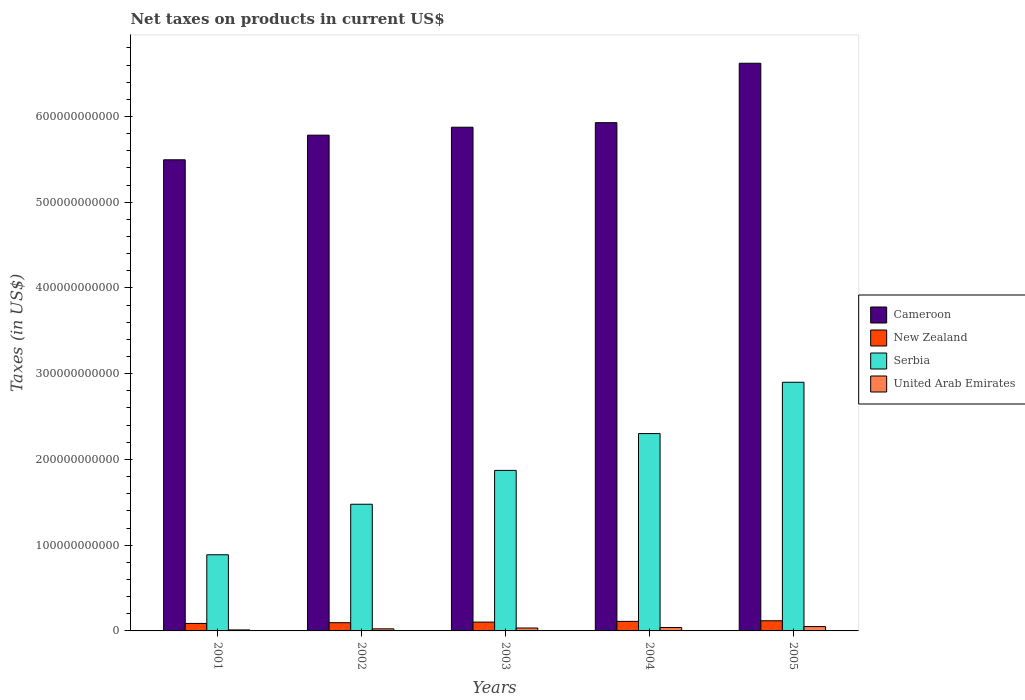Are the number of bars per tick equal to the number of legend labels?
Offer a terse response. Yes. How many bars are there on the 2nd tick from the left?
Provide a short and direct response. 4. In how many cases, is the number of bars for a given year not equal to the number of legend labels?
Your answer should be compact. 0. What is the net taxes on products in New Zealand in 2002?
Provide a succinct answer. 9.59e+09. Across all years, what is the maximum net taxes on products in Cameroon?
Your answer should be very brief. 6.62e+11. Across all years, what is the minimum net taxes on products in New Zealand?
Make the answer very short. 8.74e+09. In which year was the net taxes on products in Cameroon minimum?
Provide a succinct answer. 2001. What is the total net taxes on products in Cameroon in the graph?
Provide a short and direct response. 2.97e+12. What is the difference between the net taxes on products in United Arab Emirates in 2002 and that in 2003?
Your answer should be very brief. -9.66e+08. What is the difference between the net taxes on products in Cameroon in 2001 and the net taxes on products in New Zealand in 2002?
Provide a succinct answer. 5.40e+11. What is the average net taxes on products in Serbia per year?
Provide a succinct answer. 1.89e+11. In the year 2001, what is the difference between the net taxes on products in Serbia and net taxes on products in United Arab Emirates?
Provide a succinct answer. 8.76e+1. What is the ratio of the net taxes on products in United Arab Emirates in 2001 to that in 2005?
Ensure brevity in your answer.  0.23. Is the net taxes on products in United Arab Emirates in 2001 less than that in 2002?
Keep it short and to the point. Yes. Is the difference between the net taxes on products in Serbia in 2003 and 2004 greater than the difference between the net taxes on products in United Arab Emirates in 2003 and 2004?
Keep it short and to the point. No. What is the difference between the highest and the second highest net taxes on products in New Zealand?
Your answer should be very brief. 6.97e+08. What is the difference between the highest and the lowest net taxes on products in New Zealand?
Make the answer very short. 3.10e+09. In how many years, is the net taxes on products in New Zealand greater than the average net taxes on products in New Zealand taken over all years?
Keep it short and to the point. 2. Is the sum of the net taxes on products in United Arab Emirates in 2002 and 2004 greater than the maximum net taxes on products in New Zealand across all years?
Keep it short and to the point. No. What does the 1st bar from the left in 2003 represents?
Your answer should be very brief. Cameroon. What does the 1st bar from the right in 2001 represents?
Offer a terse response. United Arab Emirates. How many bars are there?
Offer a very short reply. 20. What is the difference between two consecutive major ticks on the Y-axis?
Make the answer very short. 1.00e+11. How many legend labels are there?
Ensure brevity in your answer.  4. What is the title of the graph?
Provide a short and direct response. Net taxes on products in current US$. What is the label or title of the X-axis?
Your answer should be compact. Years. What is the label or title of the Y-axis?
Provide a short and direct response. Taxes (in US$). What is the Taxes (in US$) of Cameroon in 2001?
Give a very brief answer. 5.49e+11. What is the Taxes (in US$) in New Zealand in 2001?
Give a very brief answer. 8.74e+09. What is the Taxes (in US$) of Serbia in 2001?
Offer a terse response. 8.88e+1. What is the Taxes (in US$) of United Arab Emirates in 2001?
Offer a terse response. 1.17e+09. What is the Taxes (in US$) in Cameroon in 2002?
Make the answer very short. 5.78e+11. What is the Taxes (in US$) in New Zealand in 2002?
Offer a terse response. 9.59e+09. What is the Taxes (in US$) in Serbia in 2002?
Offer a very short reply. 1.48e+11. What is the Taxes (in US$) of United Arab Emirates in 2002?
Provide a short and direct response. 2.43e+09. What is the Taxes (in US$) in Cameroon in 2003?
Give a very brief answer. 5.87e+11. What is the Taxes (in US$) in New Zealand in 2003?
Give a very brief answer. 1.03e+1. What is the Taxes (in US$) in Serbia in 2003?
Your answer should be compact. 1.87e+11. What is the Taxes (in US$) in United Arab Emirates in 2003?
Offer a very short reply. 3.40e+09. What is the Taxes (in US$) of Cameroon in 2004?
Offer a terse response. 5.93e+11. What is the Taxes (in US$) in New Zealand in 2004?
Make the answer very short. 1.11e+1. What is the Taxes (in US$) of Serbia in 2004?
Keep it short and to the point. 2.30e+11. What is the Taxes (in US$) in United Arab Emirates in 2004?
Provide a short and direct response. 3.94e+09. What is the Taxes (in US$) in Cameroon in 2005?
Your response must be concise. 6.62e+11. What is the Taxes (in US$) of New Zealand in 2005?
Your answer should be compact. 1.18e+1. What is the Taxes (in US$) of Serbia in 2005?
Provide a succinct answer. 2.90e+11. What is the Taxes (in US$) in United Arab Emirates in 2005?
Ensure brevity in your answer.  5.07e+09. Across all years, what is the maximum Taxes (in US$) in Cameroon?
Ensure brevity in your answer.  6.62e+11. Across all years, what is the maximum Taxes (in US$) in New Zealand?
Keep it short and to the point. 1.18e+1. Across all years, what is the maximum Taxes (in US$) in Serbia?
Offer a very short reply. 2.90e+11. Across all years, what is the maximum Taxes (in US$) of United Arab Emirates?
Your answer should be compact. 5.07e+09. Across all years, what is the minimum Taxes (in US$) of Cameroon?
Your answer should be very brief. 5.49e+11. Across all years, what is the minimum Taxes (in US$) of New Zealand?
Keep it short and to the point. 8.74e+09. Across all years, what is the minimum Taxes (in US$) in Serbia?
Provide a succinct answer. 8.88e+1. Across all years, what is the minimum Taxes (in US$) of United Arab Emirates?
Provide a short and direct response. 1.17e+09. What is the total Taxes (in US$) in Cameroon in the graph?
Keep it short and to the point. 2.97e+12. What is the total Taxes (in US$) in New Zealand in the graph?
Offer a terse response. 5.16e+1. What is the total Taxes (in US$) in Serbia in the graph?
Offer a terse response. 9.44e+11. What is the total Taxes (in US$) of United Arab Emirates in the graph?
Make the answer very short. 1.60e+1. What is the difference between the Taxes (in US$) of Cameroon in 2001 and that in 2002?
Your answer should be compact. -2.87e+1. What is the difference between the Taxes (in US$) of New Zealand in 2001 and that in 2002?
Keep it short and to the point. -8.53e+08. What is the difference between the Taxes (in US$) in Serbia in 2001 and that in 2002?
Provide a short and direct response. -5.89e+1. What is the difference between the Taxes (in US$) in United Arab Emirates in 2001 and that in 2002?
Offer a terse response. -1.26e+09. What is the difference between the Taxes (in US$) of Cameroon in 2001 and that in 2003?
Your answer should be compact. -3.80e+1. What is the difference between the Taxes (in US$) in New Zealand in 2001 and that in 2003?
Your response must be concise. -1.55e+09. What is the difference between the Taxes (in US$) of Serbia in 2001 and that in 2003?
Your answer should be compact. -9.84e+1. What is the difference between the Taxes (in US$) in United Arab Emirates in 2001 and that in 2003?
Offer a terse response. -2.23e+09. What is the difference between the Taxes (in US$) of Cameroon in 2001 and that in 2004?
Your answer should be compact. -4.33e+1. What is the difference between the Taxes (in US$) in New Zealand in 2001 and that in 2004?
Make the answer very short. -2.40e+09. What is the difference between the Taxes (in US$) of Serbia in 2001 and that in 2004?
Your response must be concise. -1.41e+11. What is the difference between the Taxes (in US$) in United Arab Emirates in 2001 and that in 2004?
Your answer should be compact. -2.77e+09. What is the difference between the Taxes (in US$) of Cameroon in 2001 and that in 2005?
Keep it short and to the point. -1.13e+11. What is the difference between the Taxes (in US$) of New Zealand in 2001 and that in 2005?
Make the answer very short. -3.10e+09. What is the difference between the Taxes (in US$) in Serbia in 2001 and that in 2005?
Your answer should be compact. -2.01e+11. What is the difference between the Taxes (in US$) in United Arab Emirates in 2001 and that in 2005?
Your response must be concise. -3.90e+09. What is the difference between the Taxes (in US$) of Cameroon in 2002 and that in 2003?
Offer a very short reply. -9.24e+09. What is the difference between the Taxes (in US$) in New Zealand in 2002 and that in 2003?
Provide a short and direct response. -6.98e+08. What is the difference between the Taxes (in US$) in Serbia in 2002 and that in 2003?
Provide a succinct answer. -3.95e+1. What is the difference between the Taxes (in US$) of United Arab Emirates in 2002 and that in 2003?
Your answer should be compact. -9.66e+08. What is the difference between the Taxes (in US$) of Cameroon in 2002 and that in 2004?
Offer a terse response. -1.46e+1. What is the difference between the Taxes (in US$) of New Zealand in 2002 and that in 2004?
Ensure brevity in your answer.  -1.55e+09. What is the difference between the Taxes (in US$) of Serbia in 2002 and that in 2004?
Your answer should be compact. -8.24e+1. What is the difference between the Taxes (in US$) of United Arab Emirates in 2002 and that in 2004?
Provide a short and direct response. -1.50e+09. What is the difference between the Taxes (in US$) of Cameroon in 2002 and that in 2005?
Keep it short and to the point. -8.39e+1. What is the difference between the Taxes (in US$) of New Zealand in 2002 and that in 2005?
Provide a short and direct response. -2.25e+09. What is the difference between the Taxes (in US$) in Serbia in 2002 and that in 2005?
Offer a terse response. -1.42e+11. What is the difference between the Taxes (in US$) of United Arab Emirates in 2002 and that in 2005?
Provide a succinct answer. -2.64e+09. What is the difference between the Taxes (in US$) in Cameroon in 2003 and that in 2004?
Keep it short and to the point. -5.34e+09. What is the difference between the Taxes (in US$) of New Zealand in 2003 and that in 2004?
Your answer should be compact. -8.52e+08. What is the difference between the Taxes (in US$) of Serbia in 2003 and that in 2004?
Offer a terse response. -4.30e+1. What is the difference between the Taxes (in US$) in United Arab Emirates in 2003 and that in 2004?
Offer a terse response. -5.39e+08. What is the difference between the Taxes (in US$) of Cameroon in 2003 and that in 2005?
Ensure brevity in your answer.  -7.46e+1. What is the difference between the Taxes (in US$) of New Zealand in 2003 and that in 2005?
Offer a very short reply. -1.55e+09. What is the difference between the Taxes (in US$) in Serbia in 2003 and that in 2005?
Your response must be concise. -1.03e+11. What is the difference between the Taxes (in US$) in United Arab Emirates in 2003 and that in 2005?
Provide a short and direct response. -1.67e+09. What is the difference between the Taxes (in US$) in Cameroon in 2004 and that in 2005?
Your response must be concise. -6.93e+1. What is the difference between the Taxes (in US$) of New Zealand in 2004 and that in 2005?
Provide a short and direct response. -6.97e+08. What is the difference between the Taxes (in US$) in Serbia in 2004 and that in 2005?
Ensure brevity in your answer.  -5.99e+1. What is the difference between the Taxes (in US$) in United Arab Emirates in 2004 and that in 2005?
Your response must be concise. -1.14e+09. What is the difference between the Taxes (in US$) of Cameroon in 2001 and the Taxes (in US$) of New Zealand in 2002?
Make the answer very short. 5.40e+11. What is the difference between the Taxes (in US$) in Cameroon in 2001 and the Taxes (in US$) in Serbia in 2002?
Offer a very short reply. 4.02e+11. What is the difference between the Taxes (in US$) in Cameroon in 2001 and the Taxes (in US$) in United Arab Emirates in 2002?
Provide a short and direct response. 5.47e+11. What is the difference between the Taxes (in US$) in New Zealand in 2001 and the Taxes (in US$) in Serbia in 2002?
Keep it short and to the point. -1.39e+11. What is the difference between the Taxes (in US$) in New Zealand in 2001 and the Taxes (in US$) in United Arab Emirates in 2002?
Your answer should be very brief. 6.31e+09. What is the difference between the Taxes (in US$) of Serbia in 2001 and the Taxes (in US$) of United Arab Emirates in 2002?
Provide a succinct answer. 8.64e+1. What is the difference between the Taxes (in US$) in Cameroon in 2001 and the Taxes (in US$) in New Zealand in 2003?
Your response must be concise. 5.39e+11. What is the difference between the Taxes (in US$) in Cameroon in 2001 and the Taxes (in US$) in Serbia in 2003?
Your answer should be very brief. 3.62e+11. What is the difference between the Taxes (in US$) of Cameroon in 2001 and the Taxes (in US$) of United Arab Emirates in 2003?
Make the answer very short. 5.46e+11. What is the difference between the Taxes (in US$) in New Zealand in 2001 and the Taxes (in US$) in Serbia in 2003?
Make the answer very short. -1.78e+11. What is the difference between the Taxes (in US$) in New Zealand in 2001 and the Taxes (in US$) in United Arab Emirates in 2003?
Offer a terse response. 5.34e+09. What is the difference between the Taxes (in US$) of Serbia in 2001 and the Taxes (in US$) of United Arab Emirates in 2003?
Give a very brief answer. 8.54e+1. What is the difference between the Taxes (in US$) of Cameroon in 2001 and the Taxes (in US$) of New Zealand in 2004?
Your response must be concise. 5.38e+11. What is the difference between the Taxes (in US$) of Cameroon in 2001 and the Taxes (in US$) of Serbia in 2004?
Offer a very short reply. 3.19e+11. What is the difference between the Taxes (in US$) of Cameroon in 2001 and the Taxes (in US$) of United Arab Emirates in 2004?
Make the answer very short. 5.46e+11. What is the difference between the Taxes (in US$) in New Zealand in 2001 and the Taxes (in US$) in Serbia in 2004?
Provide a succinct answer. -2.21e+11. What is the difference between the Taxes (in US$) of New Zealand in 2001 and the Taxes (in US$) of United Arab Emirates in 2004?
Offer a terse response. 4.80e+09. What is the difference between the Taxes (in US$) of Serbia in 2001 and the Taxes (in US$) of United Arab Emirates in 2004?
Your answer should be very brief. 8.49e+1. What is the difference between the Taxes (in US$) in Cameroon in 2001 and the Taxes (in US$) in New Zealand in 2005?
Ensure brevity in your answer.  5.38e+11. What is the difference between the Taxes (in US$) in Cameroon in 2001 and the Taxes (in US$) in Serbia in 2005?
Provide a short and direct response. 2.59e+11. What is the difference between the Taxes (in US$) of Cameroon in 2001 and the Taxes (in US$) of United Arab Emirates in 2005?
Keep it short and to the point. 5.44e+11. What is the difference between the Taxes (in US$) in New Zealand in 2001 and the Taxes (in US$) in Serbia in 2005?
Make the answer very short. -2.81e+11. What is the difference between the Taxes (in US$) in New Zealand in 2001 and the Taxes (in US$) in United Arab Emirates in 2005?
Provide a short and direct response. 3.67e+09. What is the difference between the Taxes (in US$) in Serbia in 2001 and the Taxes (in US$) in United Arab Emirates in 2005?
Provide a succinct answer. 8.37e+1. What is the difference between the Taxes (in US$) of Cameroon in 2002 and the Taxes (in US$) of New Zealand in 2003?
Ensure brevity in your answer.  5.68e+11. What is the difference between the Taxes (in US$) of Cameroon in 2002 and the Taxes (in US$) of Serbia in 2003?
Keep it short and to the point. 3.91e+11. What is the difference between the Taxes (in US$) of Cameroon in 2002 and the Taxes (in US$) of United Arab Emirates in 2003?
Your answer should be compact. 5.75e+11. What is the difference between the Taxes (in US$) in New Zealand in 2002 and the Taxes (in US$) in Serbia in 2003?
Make the answer very short. -1.78e+11. What is the difference between the Taxes (in US$) in New Zealand in 2002 and the Taxes (in US$) in United Arab Emirates in 2003?
Offer a terse response. 6.20e+09. What is the difference between the Taxes (in US$) of Serbia in 2002 and the Taxes (in US$) of United Arab Emirates in 2003?
Ensure brevity in your answer.  1.44e+11. What is the difference between the Taxes (in US$) of Cameroon in 2002 and the Taxes (in US$) of New Zealand in 2004?
Keep it short and to the point. 5.67e+11. What is the difference between the Taxes (in US$) of Cameroon in 2002 and the Taxes (in US$) of Serbia in 2004?
Provide a succinct answer. 3.48e+11. What is the difference between the Taxes (in US$) in Cameroon in 2002 and the Taxes (in US$) in United Arab Emirates in 2004?
Give a very brief answer. 5.74e+11. What is the difference between the Taxes (in US$) in New Zealand in 2002 and the Taxes (in US$) in Serbia in 2004?
Keep it short and to the point. -2.21e+11. What is the difference between the Taxes (in US$) in New Zealand in 2002 and the Taxes (in US$) in United Arab Emirates in 2004?
Provide a succinct answer. 5.66e+09. What is the difference between the Taxes (in US$) in Serbia in 2002 and the Taxes (in US$) in United Arab Emirates in 2004?
Provide a short and direct response. 1.44e+11. What is the difference between the Taxes (in US$) in Cameroon in 2002 and the Taxes (in US$) in New Zealand in 2005?
Keep it short and to the point. 5.66e+11. What is the difference between the Taxes (in US$) of Cameroon in 2002 and the Taxes (in US$) of Serbia in 2005?
Your answer should be compact. 2.88e+11. What is the difference between the Taxes (in US$) in Cameroon in 2002 and the Taxes (in US$) in United Arab Emirates in 2005?
Keep it short and to the point. 5.73e+11. What is the difference between the Taxes (in US$) in New Zealand in 2002 and the Taxes (in US$) in Serbia in 2005?
Make the answer very short. -2.80e+11. What is the difference between the Taxes (in US$) in New Zealand in 2002 and the Taxes (in US$) in United Arab Emirates in 2005?
Your answer should be compact. 4.52e+09. What is the difference between the Taxes (in US$) of Serbia in 2002 and the Taxes (in US$) of United Arab Emirates in 2005?
Provide a short and direct response. 1.43e+11. What is the difference between the Taxes (in US$) in Cameroon in 2003 and the Taxes (in US$) in New Zealand in 2004?
Ensure brevity in your answer.  5.76e+11. What is the difference between the Taxes (in US$) in Cameroon in 2003 and the Taxes (in US$) in Serbia in 2004?
Offer a terse response. 3.57e+11. What is the difference between the Taxes (in US$) in Cameroon in 2003 and the Taxes (in US$) in United Arab Emirates in 2004?
Give a very brief answer. 5.84e+11. What is the difference between the Taxes (in US$) of New Zealand in 2003 and the Taxes (in US$) of Serbia in 2004?
Your answer should be very brief. -2.20e+11. What is the difference between the Taxes (in US$) in New Zealand in 2003 and the Taxes (in US$) in United Arab Emirates in 2004?
Provide a succinct answer. 6.36e+09. What is the difference between the Taxes (in US$) in Serbia in 2003 and the Taxes (in US$) in United Arab Emirates in 2004?
Your answer should be compact. 1.83e+11. What is the difference between the Taxes (in US$) in Cameroon in 2003 and the Taxes (in US$) in New Zealand in 2005?
Your answer should be compact. 5.76e+11. What is the difference between the Taxes (in US$) of Cameroon in 2003 and the Taxes (in US$) of Serbia in 2005?
Offer a terse response. 2.97e+11. What is the difference between the Taxes (in US$) of Cameroon in 2003 and the Taxes (in US$) of United Arab Emirates in 2005?
Your answer should be very brief. 5.82e+11. What is the difference between the Taxes (in US$) of New Zealand in 2003 and the Taxes (in US$) of Serbia in 2005?
Offer a terse response. -2.80e+11. What is the difference between the Taxes (in US$) in New Zealand in 2003 and the Taxes (in US$) in United Arab Emirates in 2005?
Your answer should be compact. 5.22e+09. What is the difference between the Taxes (in US$) in Serbia in 2003 and the Taxes (in US$) in United Arab Emirates in 2005?
Keep it short and to the point. 1.82e+11. What is the difference between the Taxes (in US$) of Cameroon in 2004 and the Taxes (in US$) of New Zealand in 2005?
Give a very brief answer. 5.81e+11. What is the difference between the Taxes (in US$) in Cameroon in 2004 and the Taxes (in US$) in Serbia in 2005?
Your answer should be very brief. 3.03e+11. What is the difference between the Taxes (in US$) of Cameroon in 2004 and the Taxes (in US$) of United Arab Emirates in 2005?
Offer a very short reply. 5.88e+11. What is the difference between the Taxes (in US$) in New Zealand in 2004 and the Taxes (in US$) in Serbia in 2005?
Keep it short and to the point. -2.79e+11. What is the difference between the Taxes (in US$) of New Zealand in 2004 and the Taxes (in US$) of United Arab Emirates in 2005?
Keep it short and to the point. 6.07e+09. What is the difference between the Taxes (in US$) of Serbia in 2004 and the Taxes (in US$) of United Arab Emirates in 2005?
Provide a succinct answer. 2.25e+11. What is the average Taxes (in US$) in Cameroon per year?
Your answer should be compact. 5.94e+11. What is the average Taxes (in US$) in New Zealand per year?
Provide a succinct answer. 1.03e+1. What is the average Taxes (in US$) of Serbia per year?
Offer a terse response. 1.89e+11. What is the average Taxes (in US$) in United Arab Emirates per year?
Your answer should be compact. 3.20e+09. In the year 2001, what is the difference between the Taxes (in US$) in Cameroon and Taxes (in US$) in New Zealand?
Keep it short and to the point. 5.41e+11. In the year 2001, what is the difference between the Taxes (in US$) in Cameroon and Taxes (in US$) in Serbia?
Offer a very short reply. 4.61e+11. In the year 2001, what is the difference between the Taxes (in US$) in Cameroon and Taxes (in US$) in United Arab Emirates?
Provide a succinct answer. 5.48e+11. In the year 2001, what is the difference between the Taxes (in US$) of New Zealand and Taxes (in US$) of Serbia?
Your answer should be compact. -8.01e+1. In the year 2001, what is the difference between the Taxes (in US$) of New Zealand and Taxes (in US$) of United Arab Emirates?
Offer a very short reply. 7.57e+09. In the year 2001, what is the difference between the Taxes (in US$) in Serbia and Taxes (in US$) in United Arab Emirates?
Your response must be concise. 8.76e+1. In the year 2002, what is the difference between the Taxes (in US$) of Cameroon and Taxes (in US$) of New Zealand?
Keep it short and to the point. 5.69e+11. In the year 2002, what is the difference between the Taxes (in US$) in Cameroon and Taxes (in US$) in Serbia?
Your answer should be very brief. 4.30e+11. In the year 2002, what is the difference between the Taxes (in US$) in Cameroon and Taxes (in US$) in United Arab Emirates?
Make the answer very short. 5.76e+11. In the year 2002, what is the difference between the Taxes (in US$) of New Zealand and Taxes (in US$) of Serbia?
Provide a short and direct response. -1.38e+11. In the year 2002, what is the difference between the Taxes (in US$) of New Zealand and Taxes (in US$) of United Arab Emirates?
Your response must be concise. 7.16e+09. In the year 2002, what is the difference between the Taxes (in US$) of Serbia and Taxes (in US$) of United Arab Emirates?
Provide a short and direct response. 1.45e+11. In the year 2003, what is the difference between the Taxes (in US$) of Cameroon and Taxes (in US$) of New Zealand?
Give a very brief answer. 5.77e+11. In the year 2003, what is the difference between the Taxes (in US$) of Cameroon and Taxes (in US$) of Serbia?
Provide a short and direct response. 4.00e+11. In the year 2003, what is the difference between the Taxes (in US$) in Cameroon and Taxes (in US$) in United Arab Emirates?
Make the answer very short. 5.84e+11. In the year 2003, what is the difference between the Taxes (in US$) of New Zealand and Taxes (in US$) of Serbia?
Ensure brevity in your answer.  -1.77e+11. In the year 2003, what is the difference between the Taxes (in US$) of New Zealand and Taxes (in US$) of United Arab Emirates?
Give a very brief answer. 6.89e+09. In the year 2003, what is the difference between the Taxes (in US$) of Serbia and Taxes (in US$) of United Arab Emirates?
Provide a succinct answer. 1.84e+11. In the year 2004, what is the difference between the Taxes (in US$) in Cameroon and Taxes (in US$) in New Zealand?
Keep it short and to the point. 5.82e+11. In the year 2004, what is the difference between the Taxes (in US$) in Cameroon and Taxes (in US$) in Serbia?
Give a very brief answer. 3.63e+11. In the year 2004, what is the difference between the Taxes (in US$) of Cameroon and Taxes (in US$) of United Arab Emirates?
Provide a succinct answer. 5.89e+11. In the year 2004, what is the difference between the Taxes (in US$) in New Zealand and Taxes (in US$) in Serbia?
Provide a succinct answer. -2.19e+11. In the year 2004, what is the difference between the Taxes (in US$) of New Zealand and Taxes (in US$) of United Arab Emirates?
Provide a succinct answer. 7.21e+09. In the year 2004, what is the difference between the Taxes (in US$) of Serbia and Taxes (in US$) of United Arab Emirates?
Provide a succinct answer. 2.26e+11. In the year 2005, what is the difference between the Taxes (in US$) in Cameroon and Taxes (in US$) in New Zealand?
Make the answer very short. 6.50e+11. In the year 2005, what is the difference between the Taxes (in US$) of Cameroon and Taxes (in US$) of Serbia?
Provide a succinct answer. 3.72e+11. In the year 2005, what is the difference between the Taxes (in US$) in Cameroon and Taxes (in US$) in United Arab Emirates?
Your answer should be compact. 6.57e+11. In the year 2005, what is the difference between the Taxes (in US$) of New Zealand and Taxes (in US$) of Serbia?
Keep it short and to the point. -2.78e+11. In the year 2005, what is the difference between the Taxes (in US$) of New Zealand and Taxes (in US$) of United Arab Emirates?
Offer a very short reply. 6.77e+09. In the year 2005, what is the difference between the Taxes (in US$) in Serbia and Taxes (in US$) in United Arab Emirates?
Your answer should be very brief. 2.85e+11. What is the ratio of the Taxes (in US$) in Cameroon in 2001 to that in 2002?
Your answer should be very brief. 0.95. What is the ratio of the Taxes (in US$) in New Zealand in 2001 to that in 2002?
Provide a short and direct response. 0.91. What is the ratio of the Taxes (in US$) of Serbia in 2001 to that in 2002?
Ensure brevity in your answer.  0.6. What is the ratio of the Taxes (in US$) in United Arab Emirates in 2001 to that in 2002?
Ensure brevity in your answer.  0.48. What is the ratio of the Taxes (in US$) in Cameroon in 2001 to that in 2003?
Ensure brevity in your answer.  0.94. What is the ratio of the Taxes (in US$) of New Zealand in 2001 to that in 2003?
Offer a very short reply. 0.85. What is the ratio of the Taxes (in US$) in Serbia in 2001 to that in 2003?
Offer a very short reply. 0.47. What is the ratio of the Taxes (in US$) of United Arab Emirates in 2001 to that in 2003?
Your response must be concise. 0.34. What is the ratio of the Taxes (in US$) of Cameroon in 2001 to that in 2004?
Keep it short and to the point. 0.93. What is the ratio of the Taxes (in US$) in New Zealand in 2001 to that in 2004?
Your answer should be compact. 0.78. What is the ratio of the Taxes (in US$) in Serbia in 2001 to that in 2004?
Your response must be concise. 0.39. What is the ratio of the Taxes (in US$) in United Arab Emirates in 2001 to that in 2004?
Your answer should be very brief. 0.3. What is the ratio of the Taxes (in US$) of Cameroon in 2001 to that in 2005?
Keep it short and to the point. 0.83. What is the ratio of the Taxes (in US$) of New Zealand in 2001 to that in 2005?
Provide a short and direct response. 0.74. What is the ratio of the Taxes (in US$) in Serbia in 2001 to that in 2005?
Ensure brevity in your answer.  0.31. What is the ratio of the Taxes (in US$) of United Arab Emirates in 2001 to that in 2005?
Make the answer very short. 0.23. What is the ratio of the Taxes (in US$) in Cameroon in 2002 to that in 2003?
Keep it short and to the point. 0.98. What is the ratio of the Taxes (in US$) of New Zealand in 2002 to that in 2003?
Your answer should be very brief. 0.93. What is the ratio of the Taxes (in US$) of Serbia in 2002 to that in 2003?
Provide a short and direct response. 0.79. What is the ratio of the Taxes (in US$) of United Arab Emirates in 2002 to that in 2003?
Offer a very short reply. 0.72. What is the ratio of the Taxes (in US$) of Cameroon in 2002 to that in 2004?
Provide a short and direct response. 0.98. What is the ratio of the Taxes (in US$) in New Zealand in 2002 to that in 2004?
Your answer should be very brief. 0.86. What is the ratio of the Taxes (in US$) in Serbia in 2002 to that in 2004?
Offer a terse response. 0.64. What is the ratio of the Taxes (in US$) of United Arab Emirates in 2002 to that in 2004?
Offer a terse response. 0.62. What is the ratio of the Taxes (in US$) in Cameroon in 2002 to that in 2005?
Provide a succinct answer. 0.87. What is the ratio of the Taxes (in US$) in New Zealand in 2002 to that in 2005?
Keep it short and to the point. 0.81. What is the ratio of the Taxes (in US$) in Serbia in 2002 to that in 2005?
Your answer should be compact. 0.51. What is the ratio of the Taxes (in US$) of United Arab Emirates in 2002 to that in 2005?
Give a very brief answer. 0.48. What is the ratio of the Taxes (in US$) in Cameroon in 2003 to that in 2004?
Offer a very short reply. 0.99. What is the ratio of the Taxes (in US$) in New Zealand in 2003 to that in 2004?
Provide a short and direct response. 0.92. What is the ratio of the Taxes (in US$) in Serbia in 2003 to that in 2004?
Your answer should be very brief. 0.81. What is the ratio of the Taxes (in US$) of United Arab Emirates in 2003 to that in 2004?
Ensure brevity in your answer.  0.86. What is the ratio of the Taxes (in US$) of Cameroon in 2003 to that in 2005?
Ensure brevity in your answer.  0.89. What is the ratio of the Taxes (in US$) in New Zealand in 2003 to that in 2005?
Keep it short and to the point. 0.87. What is the ratio of the Taxes (in US$) of Serbia in 2003 to that in 2005?
Your answer should be compact. 0.65. What is the ratio of the Taxes (in US$) in United Arab Emirates in 2003 to that in 2005?
Offer a very short reply. 0.67. What is the ratio of the Taxes (in US$) in Cameroon in 2004 to that in 2005?
Make the answer very short. 0.9. What is the ratio of the Taxes (in US$) of Serbia in 2004 to that in 2005?
Your response must be concise. 0.79. What is the ratio of the Taxes (in US$) in United Arab Emirates in 2004 to that in 2005?
Offer a very short reply. 0.78. What is the difference between the highest and the second highest Taxes (in US$) in Cameroon?
Provide a short and direct response. 6.93e+1. What is the difference between the highest and the second highest Taxes (in US$) in New Zealand?
Provide a succinct answer. 6.97e+08. What is the difference between the highest and the second highest Taxes (in US$) of Serbia?
Your answer should be compact. 5.99e+1. What is the difference between the highest and the second highest Taxes (in US$) of United Arab Emirates?
Provide a short and direct response. 1.14e+09. What is the difference between the highest and the lowest Taxes (in US$) in Cameroon?
Offer a terse response. 1.13e+11. What is the difference between the highest and the lowest Taxes (in US$) in New Zealand?
Offer a terse response. 3.10e+09. What is the difference between the highest and the lowest Taxes (in US$) of Serbia?
Keep it short and to the point. 2.01e+11. What is the difference between the highest and the lowest Taxes (in US$) of United Arab Emirates?
Make the answer very short. 3.90e+09. 